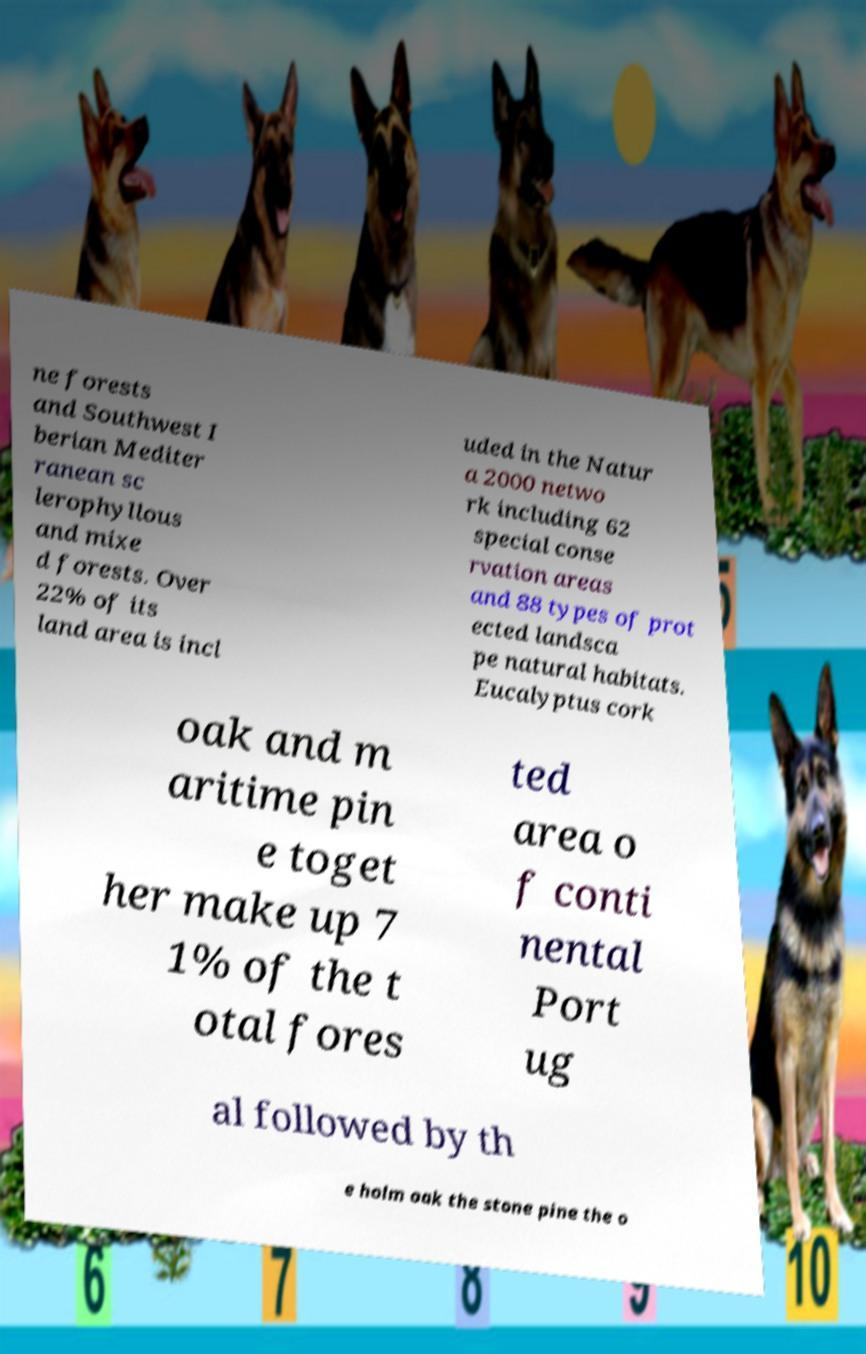Please read and relay the text visible in this image. What does it say? ne forests and Southwest I berian Mediter ranean sc lerophyllous and mixe d forests. Over 22% of its land area is incl uded in the Natur a 2000 netwo rk including 62 special conse rvation areas and 88 types of prot ected landsca pe natural habitats. Eucalyptus cork oak and m aritime pin e toget her make up 7 1% of the t otal fores ted area o f conti nental Port ug al followed by th e holm oak the stone pine the o 